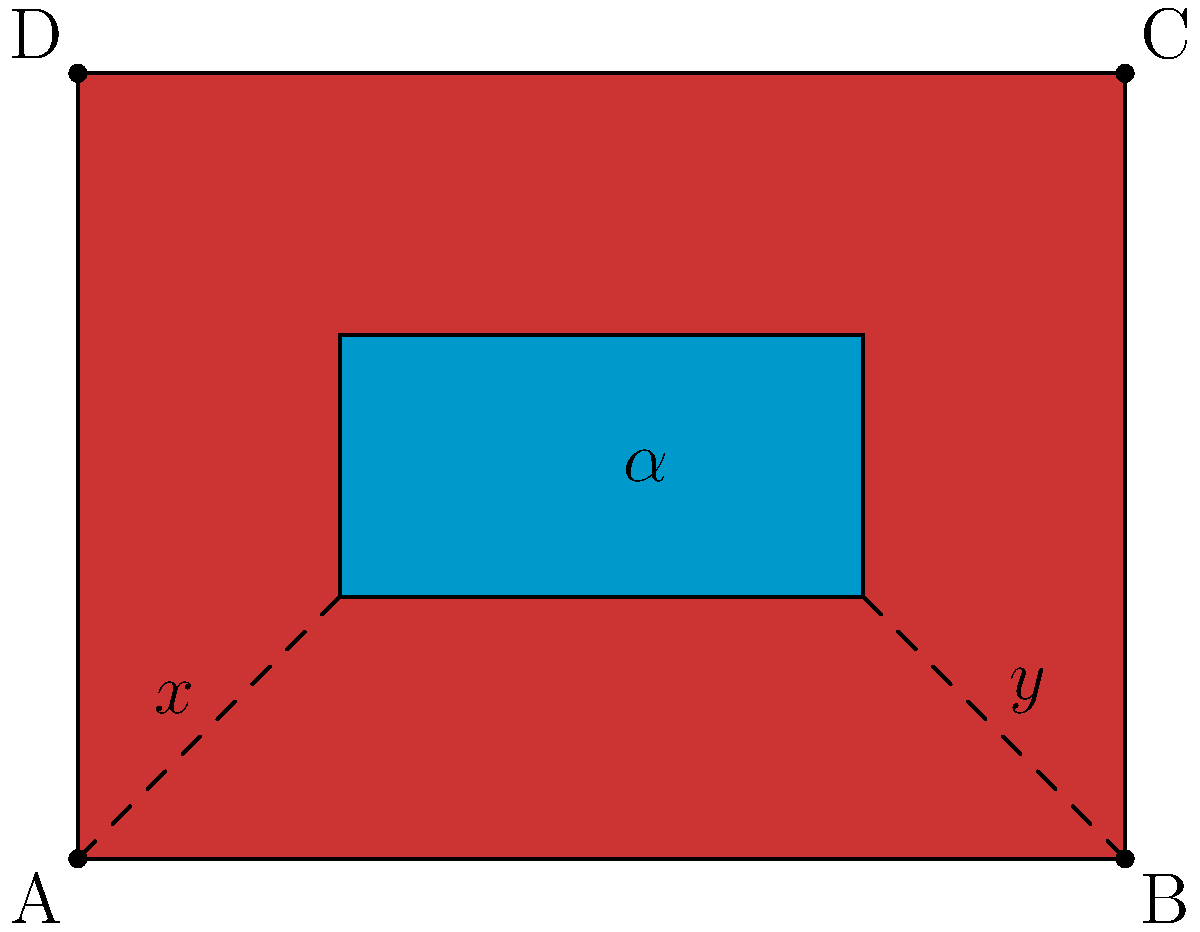In a multi-layered sosaku hanga print, two color blocks overlap to form a rectangle ABCD. If the angles formed by the overlapping region at points A and B are denoted as $x$ and $y$ respectively, what is the measure of angle $\alpha$ formed at the center of the overlapping region? To find the measure of angle $\alpha$, we can follow these steps:

1. Observe that the overlapping region forms a rectangle within the larger rectangle ABCD.

2. In a rectangle, all interior angles are 90°.

3. The angles $x$ and $y$ are complementary to the 90° angles at the corners of the overlapping rectangle. This means:
   $x + 90° = 180°$ and $y + 90° = 180°$

4. Solving these equations:
   $x = 90°$ and $y = 90°$

5. The angle $\alpha$ is formed by the intersection of two lines that are parallel to the sides of the rectangles.

6. Since $x$ and $y$ are both 90°, and $\alpha$ is formed by the intersection of lines parallel to the sides creating these angles, $\alpha$ must also be 90°.

7. This can be further confirmed by the fact that in a rectangle, diagonals bisect each other at right angles.

Therefore, the measure of angle $\alpha$ is 90°.
Answer: $90°$ 